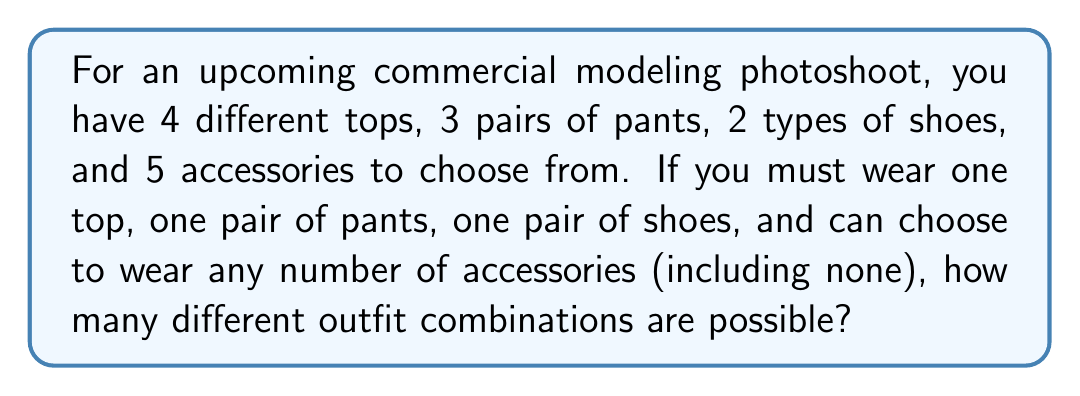Solve this math problem. Let's break this down step-by-step:

1) First, let's consider the clothing items that must be worn:
   - Tops: 4 choices
   - Pants: 3 choices
   - Shoes: 2 choices

   The number of combinations for these items is:
   $4 \times 3 \times 2 = 24$

2) Now, for the accessories, we have a different situation. We can choose to wear any number of accessories, including none. This is a case where we need to use the power set.

3) With 5 accessories, each accessory can either be worn or not worn. This gives us $2^5 = 32$ possibilities for accessories.

4) To get the total number of outfit combinations, we multiply the number of combinations for the required items by the number of accessory combinations:

   $24 \times 32 = 768$

Thus, the total number of possible outfit combinations can be expressed as:

$$4 \times 3 \times 2 \times 2^5 = 768$$
Answer: 768 